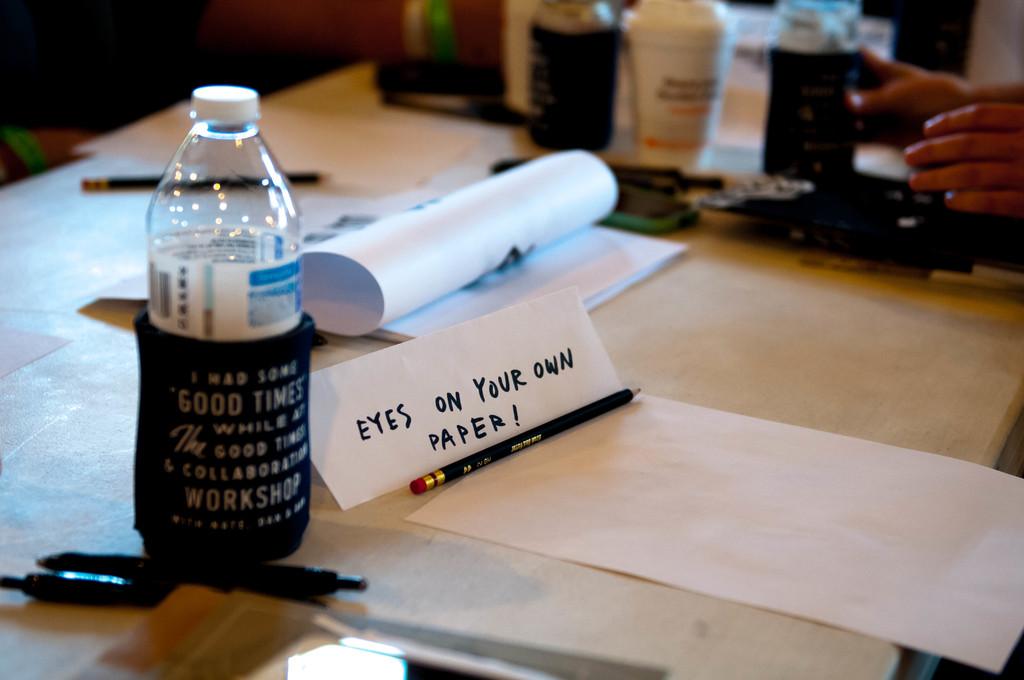Where do you keep your eyes?
Offer a terse response. On your own paper. What kind of "times" is on the koozie?
Provide a short and direct response. Good. 